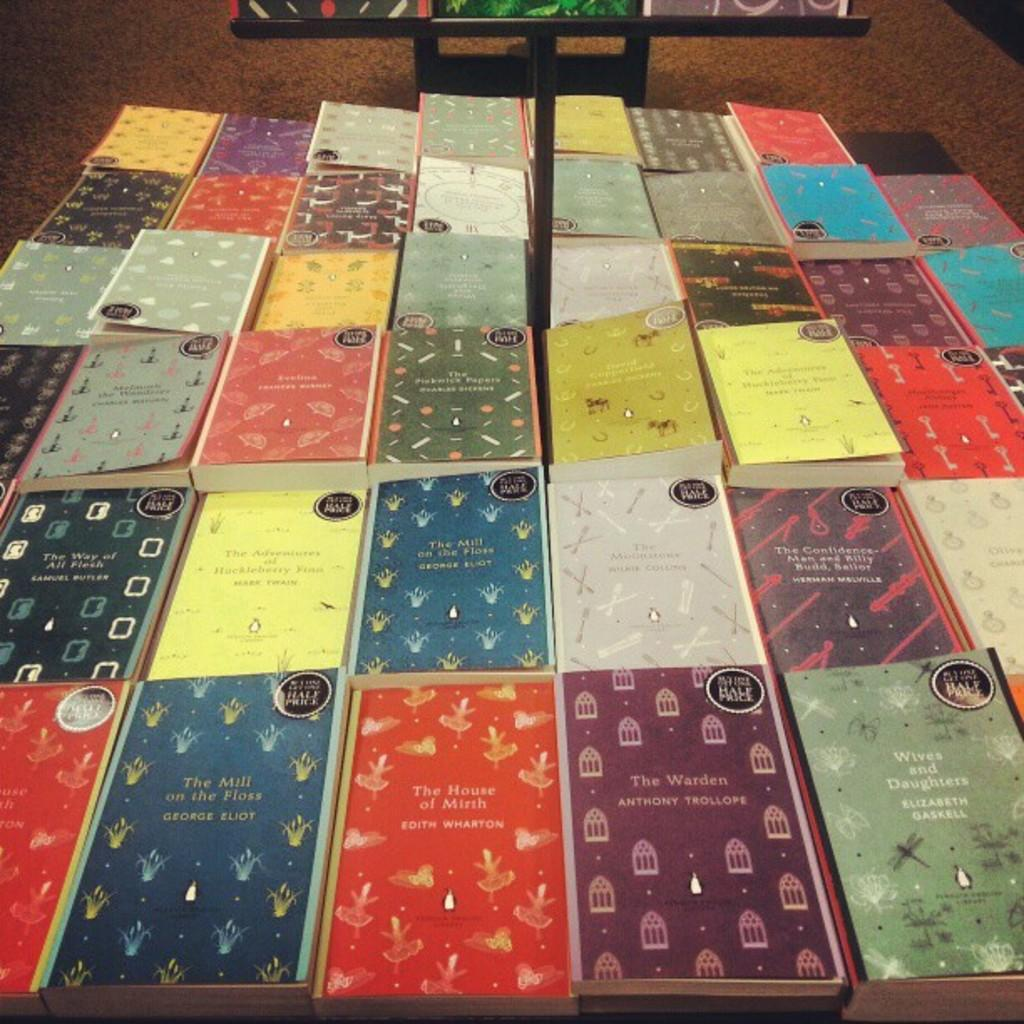What objects can be seen in the image? There are books in the image. Where are the books located? The books are placed on a table. How many passengers are on the plane in the image? There is no plane or passengers present in the image; it only features books on a table. 